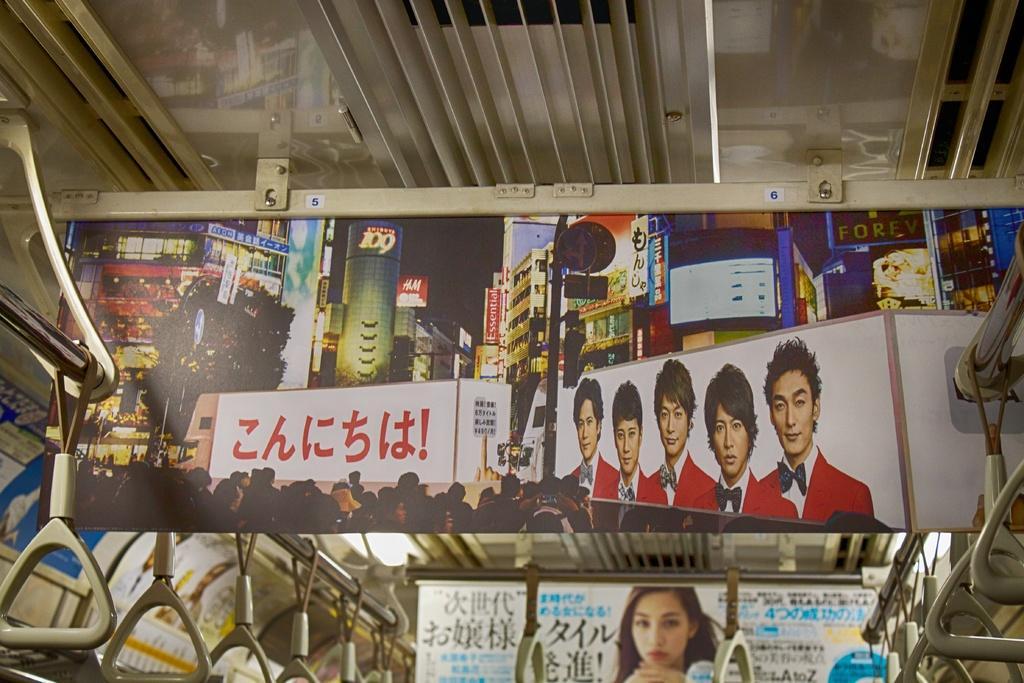Describe this image in one or two sentences. In this image there is a poster, on that poster there are people, building, and text, on either side of the poster there are rods, for that roads there hangers and the top there is a roof and in the background there is another poster, on that poster there is a woman and some text. 